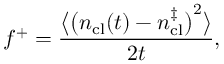<formula> <loc_0><loc_0><loc_500><loc_500>f ^ { + } = \frac { \left \langle \left ( n _ { c l } ( t ) - n _ { c l } ^ { \ddagger } \right ) ^ { 2 } \right \rangle } { 2 t } ,</formula> 